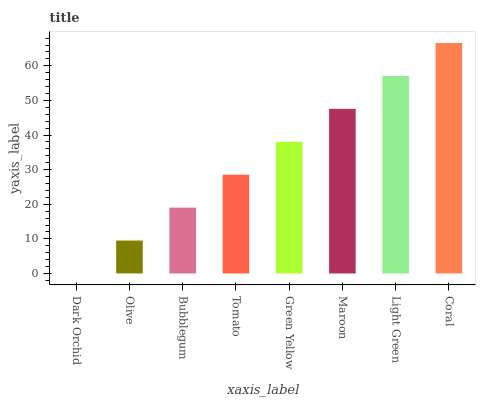Is Dark Orchid the minimum?
Answer yes or no. Yes. Is Coral the maximum?
Answer yes or no. Yes. Is Olive the minimum?
Answer yes or no. No. Is Olive the maximum?
Answer yes or no. No. Is Olive greater than Dark Orchid?
Answer yes or no. Yes. Is Dark Orchid less than Olive?
Answer yes or no. Yes. Is Dark Orchid greater than Olive?
Answer yes or no. No. Is Olive less than Dark Orchid?
Answer yes or no. No. Is Green Yellow the high median?
Answer yes or no. Yes. Is Tomato the low median?
Answer yes or no. Yes. Is Dark Orchid the high median?
Answer yes or no. No. Is Dark Orchid the low median?
Answer yes or no. No. 